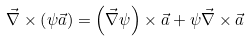<formula> <loc_0><loc_0><loc_500><loc_500>\vec { \nabla } \times \left ( \psi \vec { a } \right ) = \left ( \vec { \nabla } \psi \right ) \times \vec { a } + \psi \vec { \nabla } \times \vec { a }</formula> 